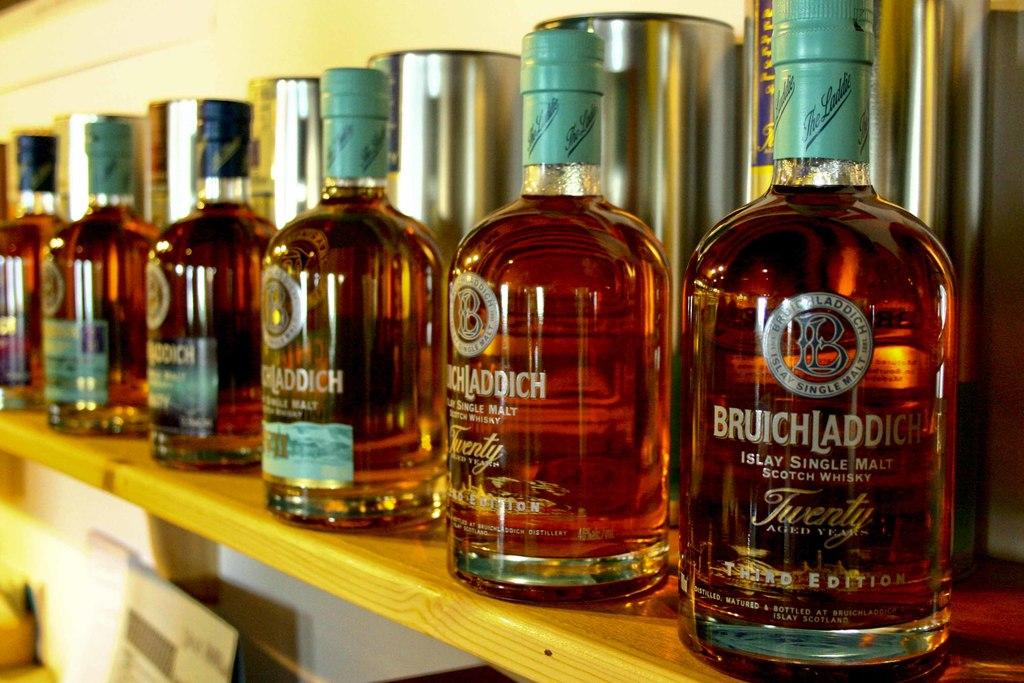<image>
Summarize the visual content of the image. several bottles of Islay Single Malt Scotch Whisky on display 